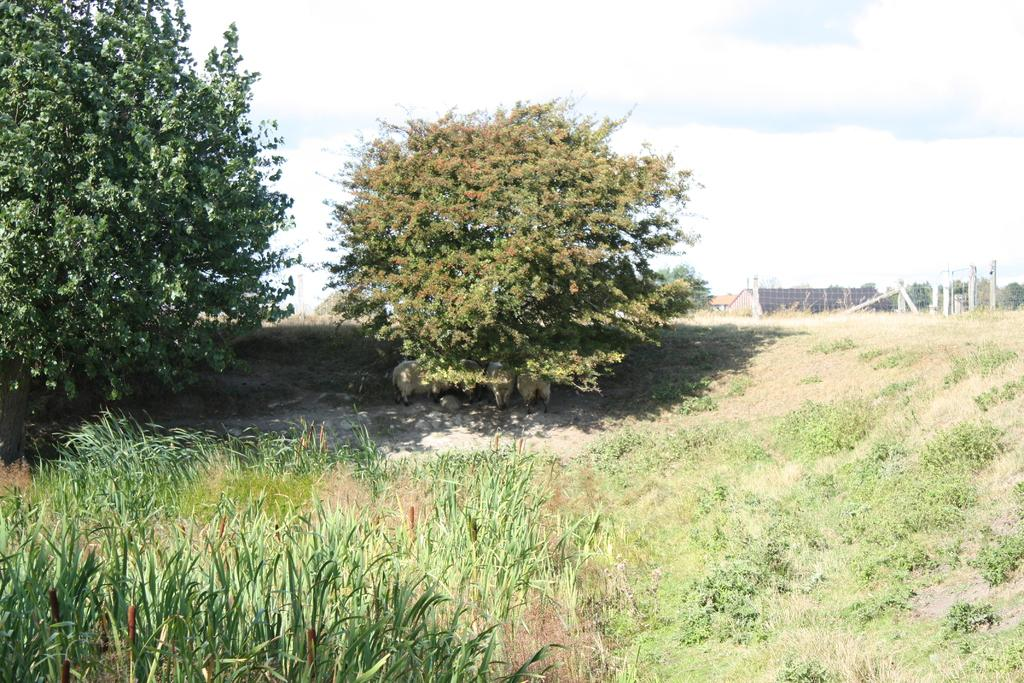What type of vegetation is present on the ground in the image? There is grass on the ground in the front of the image. What can be seen in the background of the image? There are trees, a wall, and poles in the background of the image. What is the condition of the sky in the image? The sky is cloudy in the image. How many books are stacked on the bread in the image? There are no books or bread present in the image. 